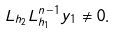<formula> <loc_0><loc_0><loc_500><loc_500>L _ { h _ { 2 } } L _ { h _ { 1 } } ^ { n - 1 } y _ { 1 } \not = 0 .</formula> 